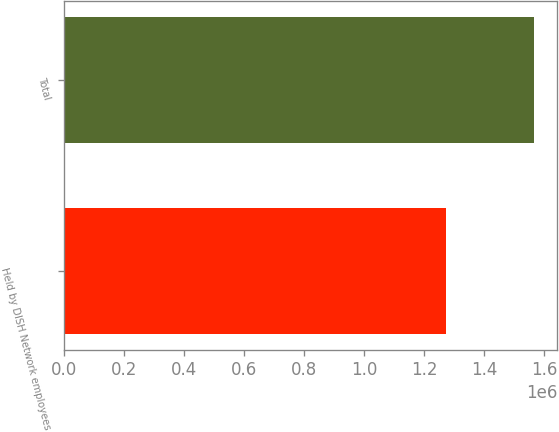Convert chart to OTSL. <chart><loc_0><loc_0><loc_500><loc_500><bar_chart><fcel>Held by DISH Network employees<fcel>Total<nl><fcel>1.27198e+06<fcel>1.56433e+06<nl></chart> 